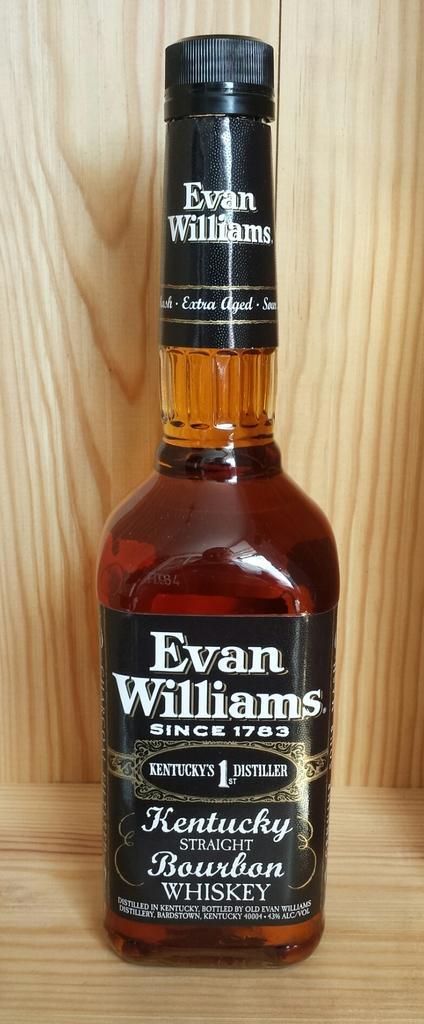Please provide a concise description of this image. This is a whisky bottle and it is having a wooden background. 